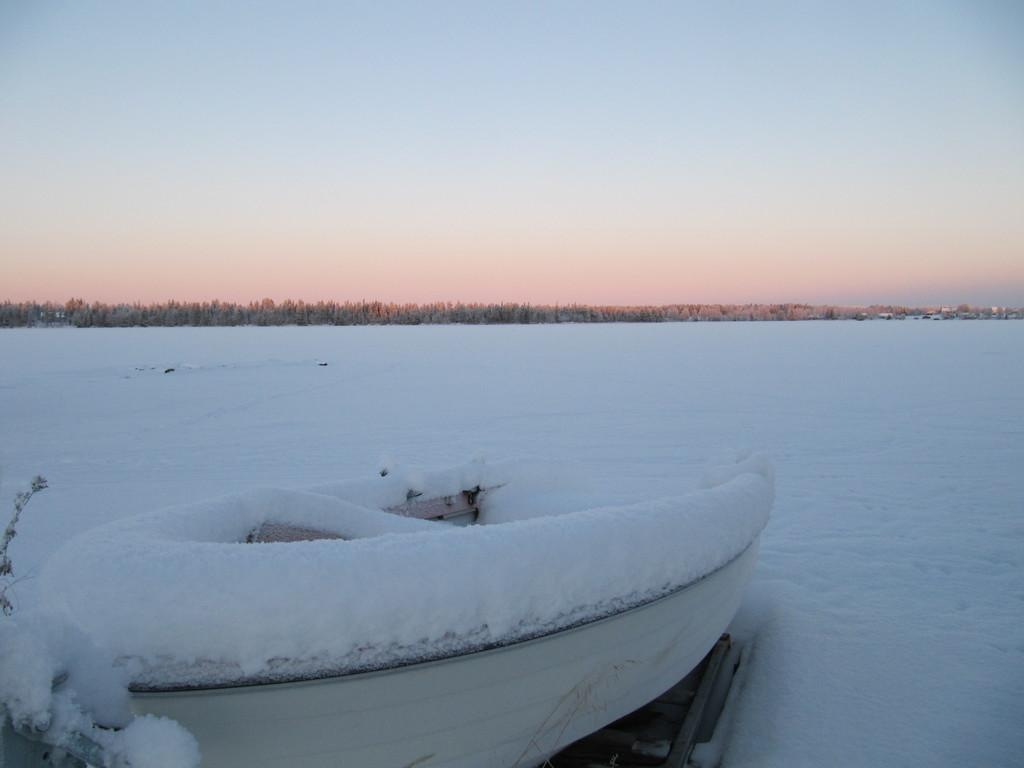What type of boat is in the image? There is a white color boat in the image. What is covering the boat? There is snow on the boat. What is the ground surface like near the boat? There is a snow surface on the ground beside the boat. What can be seen in the background of the image? There are trees in the background of the image, and the sky is blue. What type of linen is draped over the trees in the image? There is no linen draped over the trees in the image; the trees are in the background with a blue sky. What fruit can be seen hanging from the branches of the trees in the image? There is no fruit visible on the trees in the image; only snow is present on the boat and ground. 